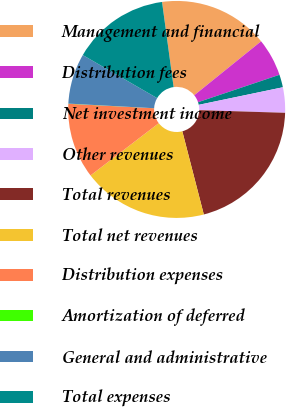<chart> <loc_0><loc_0><loc_500><loc_500><pie_chart><fcel>Management and financial<fcel>Distribution fees<fcel>Net investment income<fcel>Other revenues<fcel>Total revenues<fcel>Total net revenues<fcel>Distribution expenses<fcel>Amortization of deferred<fcel>General and administrative<fcel>Total expenses<nl><fcel>16.35%<fcel>5.63%<fcel>1.9%<fcel>3.77%<fcel>20.48%<fcel>18.62%<fcel>11.23%<fcel>0.03%<fcel>7.5%<fcel>14.49%<nl></chart> 